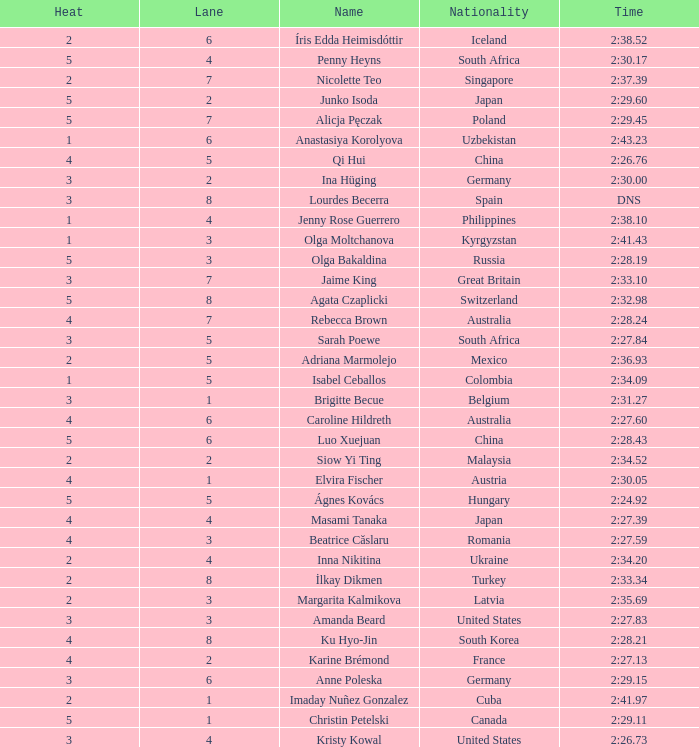What is the name that saw 4 heats and a lane higher than 7? Ku Hyo-Jin. 